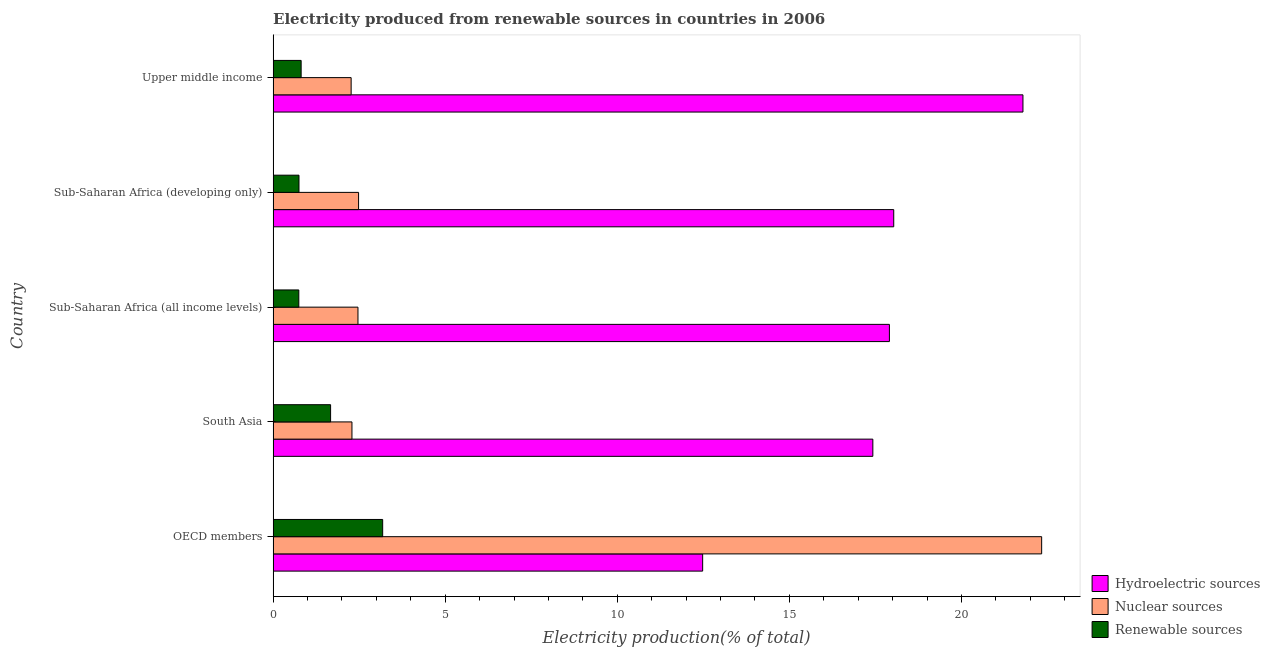How many different coloured bars are there?
Keep it short and to the point. 3. Are the number of bars per tick equal to the number of legend labels?
Ensure brevity in your answer.  Yes. Are the number of bars on each tick of the Y-axis equal?
Offer a terse response. Yes. How many bars are there on the 2nd tick from the bottom?
Offer a very short reply. 3. In how many cases, is the number of bars for a given country not equal to the number of legend labels?
Make the answer very short. 0. What is the percentage of electricity produced by nuclear sources in South Asia?
Provide a succinct answer. 2.29. Across all countries, what is the maximum percentage of electricity produced by renewable sources?
Your answer should be compact. 3.18. Across all countries, what is the minimum percentage of electricity produced by renewable sources?
Give a very brief answer. 0.75. In which country was the percentage of electricity produced by renewable sources minimum?
Ensure brevity in your answer.  Sub-Saharan Africa (all income levels). What is the total percentage of electricity produced by hydroelectric sources in the graph?
Your answer should be very brief. 87.63. What is the difference between the percentage of electricity produced by renewable sources in OECD members and that in South Asia?
Offer a terse response. 1.51. What is the difference between the percentage of electricity produced by renewable sources in Sub-Saharan Africa (developing only) and the percentage of electricity produced by hydroelectric sources in OECD members?
Make the answer very short. -11.73. What is the average percentage of electricity produced by nuclear sources per country?
Your answer should be very brief. 6.37. What is the difference between the percentage of electricity produced by hydroelectric sources and percentage of electricity produced by renewable sources in Upper middle income?
Offer a very short reply. 20.97. What is the ratio of the percentage of electricity produced by hydroelectric sources in OECD members to that in Sub-Saharan Africa (developing only)?
Provide a short and direct response. 0.69. Is the percentage of electricity produced by renewable sources in OECD members less than that in Sub-Saharan Africa (developing only)?
Your answer should be very brief. No. What is the difference between the highest and the second highest percentage of electricity produced by renewable sources?
Provide a succinct answer. 1.51. What is the difference between the highest and the lowest percentage of electricity produced by nuclear sources?
Your answer should be compact. 20.06. In how many countries, is the percentage of electricity produced by renewable sources greater than the average percentage of electricity produced by renewable sources taken over all countries?
Offer a very short reply. 2. Is the sum of the percentage of electricity produced by renewable sources in OECD members and South Asia greater than the maximum percentage of electricity produced by hydroelectric sources across all countries?
Your answer should be very brief. No. What does the 3rd bar from the top in South Asia represents?
Your response must be concise. Hydroelectric sources. What does the 2nd bar from the bottom in Sub-Saharan Africa (developing only) represents?
Offer a very short reply. Nuclear sources. Is it the case that in every country, the sum of the percentage of electricity produced by hydroelectric sources and percentage of electricity produced by nuclear sources is greater than the percentage of electricity produced by renewable sources?
Keep it short and to the point. Yes. How many bars are there?
Provide a succinct answer. 15. What is the difference between two consecutive major ticks on the X-axis?
Your answer should be very brief. 5. Does the graph contain any zero values?
Offer a very short reply. No. How are the legend labels stacked?
Your answer should be compact. Vertical. What is the title of the graph?
Offer a very short reply. Electricity produced from renewable sources in countries in 2006. What is the label or title of the X-axis?
Keep it short and to the point. Electricity production(% of total). What is the Electricity production(% of total) of Hydroelectric sources in OECD members?
Keep it short and to the point. 12.48. What is the Electricity production(% of total) of Nuclear sources in OECD members?
Your answer should be compact. 22.33. What is the Electricity production(% of total) of Renewable sources in OECD members?
Offer a very short reply. 3.18. What is the Electricity production(% of total) of Hydroelectric sources in South Asia?
Your response must be concise. 17.43. What is the Electricity production(% of total) in Nuclear sources in South Asia?
Offer a very short reply. 2.29. What is the Electricity production(% of total) of Renewable sources in South Asia?
Your answer should be very brief. 1.67. What is the Electricity production(% of total) of Hydroelectric sources in Sub-Saharan Africa (all income levels)?
Offer a terse response. 17.91. What is the Electricity production(% of total) of Nuclear sources in Sub-Saharan Africa (all income levels)?
Your answer should be very brief. 2.47. What is the Electricity production(% of total) of Renewable sources in Sub-Saharan Africa (all income levels)?
Provide a succinct answer. 0.75. What is the Electricity production(% of total) in Hydroelectric sources in Sub-Saharan Africa (developing only)?
Offer a terse response. 18.03. What is the Electricity production(% of total) of Nuclear sources in Sub-Saharan Africa (developing only)?
Provide a short and direct response. 2.48. What is the Electricity production(% of total) of Renewable sources in Sub-Saharan Africa (developing only)?
Your answer should be very brief. 0.75. What is the Electricity production(% of total) in Hydroelectric sources in Upper middle income?
Ensure brevity in your answer.  21.79. What is the Electricity production(% of total) of Nuclear sources in Upper middle income?
Keep it short and to the point. 2.27. What is the Electricity production(% of total) of Renewable sources in Upper middle income?
Offer a terse response. 0.81. Across all countries, what is the maximum Electricity production(% of total) of Hydroelectric sources?
Your answer should be compact. 21.79. Across all countries, what is the maximum Electricity production(% of total) in Nuclear sources?
Your answer should be very brief. 22.33. Across all countries, what is the maximum Electricity production(% of total) in Renewable sources?
Provide a succinct answer. 3.18. Across all countries, what is the minimum Electricity production(% of total) of Hydroelectric sources?
Your answer should be very brief. 12.48. Across all countries, what is the minimum Electricity production(% of total) in Nuclear sources?
Ensure brevity in your answer.  2.27. Across all countries, what is the minimum Electricity production(% of total) in Renewable sources?
Make the answer very short. 0.75. What is the total Electricity production(% of total) of Hydroelectric sources in the graph?
Provide a short and direct response. 87.63. What is the total Electricity production(% of total) in Nuclear sources in the graph?
Your answer should be very brief. 31.84. What is the total Electricity production(% of total) of Renewable sources in the graph?
Your answer should be compact. 7.17. What is the difference between the Electricity production(% of total) of Hydroelectric sources in OECD members and that in South Asia?
Your response must be concise. -4.95. What is the difference between the Electricity production(% of total) in Nuclear sources in OECD members and that in South Asia?
Provide a succinct answer. 20.04. What is the difference between the Electricity production(% of total) in Renewable sources in OECD members and that in South Asia?
Your answer should be very brief. 1.51. What is the difference between the Electricity production(% of total) of Hydroelectric sources in OECD members and that in Sub-Saharan Africa (all income levels)?
Provide a short and direct response. -5.43. What is the difference between the Electricity production(% of total) of Nuclear sources in OECD members and that in Sub-Saharan Africa (all income levels)?
Provide a succinct answer. 19.86. What is the difference between the Electricity production(% of total) of Renewable sources in OECD members and that in Sub-Saharan Africa (all income levels)?
Give a very brief answer. 2.44. What is the difference between the Electricity production(% of total) of Hydroelectric sources in OECD members and that in Sub-Saharan Africa (developing only)?
Your response must be concise. -5.55. What is the difference between the Electricity production(% of total) in Nuclear sources in OECD members and that in Sub-Saharan Africa (developing only)?
Your response must be concise. 19.85. What is the difference between the Electricity production(% of total) of Renewable sources in OECD members and that in Sub-Saharan Africa (developing only)?
Keep it short and to the point. 2.43. What is the difference between the Electricity production(% of total) of Hydroelectric sources in OECD members and that in Upper middle income?
Provide a succinct answer. -9.31. What is the difference between the Electricity production(% of total) of Nuclear sources in OECD members and that in Upper middle income?
Your answer should be very brief. 20.06. What is the difference between the Electricity production(% of total) of Renewable sources in OECD members and that in Upper middle income?
Offer a very short reply. 2.37. What is the difference between the Electricity production(% of total) in Hydroelectric sources in South Asia and that in Sub-Saharan Africa (all income levels)?
Your answer should be compact. -0.48. What is the difference between the Electricity production(% of total) of Nuclear sources in South Asia and that in Sub-Saharan Africa (all income levels)?
Your response must be concise. -0.17. What is the difference between the Electricity production(% of total) in Renewable sources in South Asia and that in Sub-Saharan Africa (all income levels)?
Provide a succinct answer. 0.92. What is the difference between the Electricity production(% of total) of Hydroelectric sources in South Asia and that in Sub-Saharan Africa (developing only)?
Keep it short and to the point. -0.61. What is the difference between the Electricity production(% of total) of Nuclear sources in South Asia and that in Sub-Saharan Africa (developing only)?
Provide a succinct answer. -0.19. What is the difference between the Electricity production(% of total) of Renewable sources in South Asia and that in Sub-Saharan Africa (developing only)?
Your response must be concise. 0.92. What is the difference between the Electricity production(% of total) in Hydroelectric sources in South Asia and that in Upper middle income?
Give a very brief answer. -4.36. What is the difference between the Electricity production(% of total) in Nuclear sources in South Asia and that in Upper middle income?
Provide a short and direct response. 0.02. What is the difference between the Electricity production(% of total) in Renewable sources in South Asia and that in Upper middle income?
Offer a very short reply. 0.86. What is the difference between the Electricity production(% of total) in Hydroelectric sources in Sub-Saharan Africa (all income levels) and that in Sub-Saharan Africa (developing only)?
Your answer should be compact. -0.13. What is the difference between the Electricity production(% of total) of Nuclear sources in Sub-Saharan Africa (all income levels) and that in Sub-Saharan Africa (developing only)?
Provide a succinct answer. -0.02. What is the difference between the Electricity production(% of total) in Renewable sources in Sub-Saharan Africa (all income levels) and that in Sub-Saharan Africa (developing only)?
Ensure brevity in your answer.  -0.01. What is the difference between the Electricity production(% of total) in Hydroelectric sources in Sub-Saharan Africa (all income levels) and that in Upper middle income?
Your answer should be compact. -3.88. What is the difference between the Electricity production(% of total) of Nuclear sources in Sub-Saharan Africa (all income levels) and that in Upper middle income?
Your answer should be compact. 0.2. What is the difference between the Electricity production(% of total) in Renewable sources in Sub-Saharan Africa (all income levels) and that in Upper middle income?
Your answer should be compact. -0.07. What is the difference between the Electricity production(% of total) in Hydroelectric sources in Sub-Saharan Africa (developing only) and that in Upper middle income?
Offer a very short reply. -3.75. What is the difference between the Electricity production(% of total) in Nuclear sources in Sub-Saharan Africa (developing only) and that in Upper middle income?
Offer a very short reply. 0.22. What is the difference between the Electricity production(% of total) in Renewable sources in Sub-Saharan Africa (developing only) and that in Upper middle income?
Provide a short and direct response. -0.06. What is the difference between the Electricity production(% of total) in Hydroelectric sources in OECD members and the Electricity production(% of total) in Nuclear sources in South Asia?
Keep it short and to the point. 10.19. What is the difference between the Electricity production(% of total) in Hydroelectric sources in OECD members and the Electricity production(% of total) in Renewable sources in South Asia?
Keep it short and to the point. 10.81. What is the difference between the Electricity production(% of total) of Nuclear sources in OECD members and the Electricity production(% of total) of Renewable sources in South Asia?
Your answer should be very brief. 20.66. What is the difference between the Electricity production(% of total) of Hydroelectric sources in OECD members and the Electricity production(% of total) of Nuclear sources in Sub-Saharan Africa (all income levels)?
Your answer should be compact. 10.01. What is the difference between the Electricity production(% of total) of Hydroelectric sources in OECD members and the Electricity production(% of total) of Renewable sources in Sub-Saharan Africa (all income levels)?
Your answer should be compact. 11.73. What is the difference between the Electricity production(% of total) in Nuclear sources in OECD members and the Electricity production(% of total) in Renewable sources in Sub-Saharan Africa (all income levels)?
Ensure brevity in your answer.  21.58. What is the difference between the Electricity production(% of total) of Hydroelectric sources in OECD members and the Electricity production(% of total) of Nuclear sources in Sub-Saharan Africa (developing only)?
Ensure brevity in your answer.  10. What is the difference between the Electricity production(% of total) in Hydroelectric sources in OECD members and the Electricity production(% of total) in Renewable sources in Sub-Saharan Africa (developing only)?
Your answer should be very brief. 11.73. What is the difference between the Electricity production(% of total) of Nuclear sources in OECD members and the Electricity production(% of total) of Renewable sources in Sub-Saharan Africa (developing only)?
Give a very brief answer. 21.58. What is the difference between the Electricity production(% of total) of Hydroelectric sources in OECD members and the Electricity production(% of total) of Nuclear sources in Upper middle income?
Offer a terse response. 10.21. What is the difference between the Electricity production(% of total) in Hydroelectric sources in OECD members and the Electricity production(% of total) in Renewable sources in Upper middle income?
Give a very brief answer. 11.67. What is the difference between the Electricity production(% of total) of Nuclear sources in OECD members and the Electricity production(% of total) of Renewable sources in Upper middle income?
Keep it short and to the point. 21.52. What is the difference between the Electricity production(% of total) in Hydroelectric sources in South Asia and the Electricity production(% of total) in Nuclear sources in Sub-Saharan Africa (all income levels)?
Your answer should be very brief. 14.96. What is the difference between the Electricity production(% of total) in Hydroelectric sources in South Asia and the Electricity production(% of total) in Renewable sources in Sub-Saharan Africa (all income levels)?
Give a very brief answer. 16.68. What is the difference between the Electricity production(% of total) in Nuclear sources in South Asia and the Electricity production(% of total) in Renewable sources in Sub-Saharan Africa (all income levels)?
Offer a very short reply. 1.54. What is the difference between the Electricity production(% of total) in Hydroelectric sources in South Asia and the Electricity production(% of total) in Nuclear sources in Sub-Saharan Africa (developing only)?
Your response must be concise. 14.94. What is the difference between the Electricity production(% of total) of Hydroelectric sources in South Asia and the Electricity production(% of total) of Renewable sources in Sub-Saharan Africa (developing only)?
Ensure brevity in your answer.  16.67. What is the difference between the Electricity production(% of total) of Nuclear sources in South Asia and the Electricity production(% of total) of Renewable sources in Sub-Saharan Africa (developing only)?
Your response must be concise. 1.54. What is the difference between the Electricity production(% of total) of Hydroelectric sources in South Asia and the Electricity production(% of total) of Nuclear sources in Upper middle income?
Keep it short and to the point. 15.16. What is the difference between the Electricity production(% of total) of Hydroelectric sources in South Asia and the Electricity production(% of total) of Renewable sources in Upper middle income?
Ensure brevity in your answer.  16.61. What is the difference between the Electricity production(% of total) of Nuclear sources in South Asia and the Electricity production(% of total) of Renewable sources in Upper middle income?
Your answer should be very brief. 1.48. What is the difference between the Electricity production(% of total) in Hydroelectric sources in Sub-Saharan Africa (all income levels) and the Electricity production(% of total) in Nuclear sources in Sub-Saharan Africa (developing only)?
Keep it short and to the point. 15.42. What is the difference between the Electricity production(% of total) of Hydroelectric sources in Sub-Saharan Africa (all income levels) and the Electricity production(% of total) of Renewable sources in Sub-Saharan Africa (developing only)?
Make the answer very short. 17.15. What is the difference between the Electricity production(% of total) in Nuclear sources in Sub-Saharan Africa (all income levels) and the Electricity production(% of total) in Renewable sources in Sub-Saharan Africa (developing only)?
Your answer should be very brief. 1.71. What is the difference between the Electricity production(% of total) of Hydroelectric sources in Sub-Saharan Africa (all income levels) and the Electricity production(% of total) of Nuclear sources in Upper middle income?
Offer a terse response. 15.64. What is the difference between the Electricity production(% of total) of Hydroelectric sources in Sub-Saharan Africa (all income levels) and the Electricity production(% of total) of Renewable sources in Upper middle income?
Offer a terse response. 17.09. What is the difference between the Electricity production(% of total) of Nuclear sources in Sub-Saharan Africa (all income levels) and the Electricity production(% of total) of Renewable sources in Upper middle income?
Provide a succinct answer. 1.65. What is the difference between the Electricity production(% of total) of Hydroelectric sources in Sub-Saharan Africa (developing only) and the Electricity production(% of total) of Nuclear sources in Upper middle income?
Keep it short and to the point. 15.76. What is the difference between the Electricity production(% of total) in Hydroelectric sources in Sub-Saharan Africa (developing only) and the Electricity production(% of total) in Renewable sources in Upper middle income?
Provide a succinct answer. 17.22. What is the difference between the Electricity production(% of total) in Nuclear sources in Sub-Saharan Africa (developing only) and the Electricity production(% of total) in Renewable sources in Upper middle income?
Give a very brief answer. 1.67. What is the average Electricity production(% of total) in Hydroelectric sources per country?
Make the answer very short. 17.53. What is the average Electricity production(% of total) in Nuclear sources per country?
Ensure brevity in your answer.  6.37. What is the average Electricity production(% of total) of Renewable sources per country?
Offer a terse response. 1.43. What is the difference between the Electricity production(% of total) in Hydroelectric sources and Electricity production(% of total) in Nuclear sources in OECD members?
Keep it short and to the point. -9.85. What is the difference between the Electricity production(% of total) of Hydroelectric sources and Electricity production(% of total) of Renewable sources in OECD members?
Give a very brief answer. 9.3. What is the difference between the Electricity production(% of total) in Nuclear sources and Electricity production(% of total) in Renewable sources in OECD members?
Your answer should be very brief. 19.15. What is the difference between the Electricity production(% of total) in Hydroelectric sources and Electricity production(% of total) in Nuclear sources in South Asia?
Offer a very short reply. 15.13. What is the difference between the Electricity production(% of total) of Hydroelectric sources and Electricity production(% of total) of Renewable sources in South Asia?
Your response must be concise. 15.76. What is the difference between the Electricity production(% of total) in Nuclear sources and Electricity production(% of total) in Renewable sources in South Asia?
Your response must be concise. 0.62. What is the difference between the Electricity production(% of total) of Hydroelectric sources and Electricity production(% of total) of Nuclear sources in Sub-Saharan Africa (all income levels)?
Your answer should be very brief. 15.44. What is the difference between the Electricity production(% of total) of Hydroelectric sources and Electricity production(% of total) of Renewable sources in Sub-Saharan Africa (all income levels)?
Your answer should be very brief. 17.16. What is the difference between the Electricity production(% of total) of Nuclear sources and Electricity production(% of total) of Renewable sources in Sub-Saharan Africa (all income levels)?
Your response must be concise. 1.72. What is the difference between the Electricity production(% of total) of Hydroelectric sources and Electricity production(% of total) of Nuclear sources in Sub-Saharan Africa (developing only)?
Provide a succinct answer. 15.55. What is the difference between the Electricity production(% of total) of Hydroelectric sources and Electricity production(% of total) of Renewable sources in Sub-Saharan Africa (developing only)?
Make the answer very short. 17.28. What is the difference between the Electricity production(% of total) in Nuclear sources and Electricity production(% of total) in Renewable sources in Sub-Saharan Africa (developing only)?
Offer a very short reply. 1.73. What is the difference between the Electricity production(% of total) of Hydroelectric sources and Electricity production(% of total) of Nuclear sources in Upper middle income?
Offer a terse response. 19.52. What is the difference between the Electricity production(% of total) in Hydroelectric sources and Electricity production(% of total) in Renewable sources in Upper middle income?
Provide a succinct answer. 20.97. What is the difference between the Electricity production(% of total) in Nuclear sources and Electricity production(% of total) in Renewable sources in Upper middle income?
Your response must be concise. 1.45. What is the ratio of the Electricity production(% of total) of Hydroelectric sources in OECD members to that in South Asia?
Make the answer very short. 0.72. What is the ratio of the Electricity production(% of total) of Nuclear sources in OECD members to that in South Asia?
Offer a very short reply. 9.75. What is the ratio of the Electricity production(% of total) in Renewable sources in OECD members to that in South Asia?
Offer a terse response. 1.91. What is the ratio of the Electricity production(% of total) in Hydroelectric sources in OECD members to that in Sub-Saharan Africa (all income levels)?
Offer a very short reply. 0.7. What is the ratio of the Electricity production(% of total) of Nuclear sources in OECD members to that in Sub-Saharan Africa (all income levels)?
Your answer should be very brief. 9.06. What is the ratio of the Electricity production(% of total) of Renewable sources in OECD members to that in Sub-Saharan Africa (all income levels)?
Keep it short and to the point. 4.26. What is the ratio of the Electricity production(% of total) of Hydroelectric sources in OECD members to that in Sub-Saharan Africa (developing only)?
Your answer should be compact. 0.69. What is the ratio of the Electricity production(% of total) of Nuclear sources in OECD members to that in Sub-Saharan Africa (developing only)?
Give a very brief answer. 8.99. What is the ratio of the Electricity production(% of total) in Renewable sources in OECD members to that in Sub-Saharan Africa (developing only)?
Provide a succinct answer. 4.24. What is the ratio of the Electricity production(% of total) of Hydroelectric sources in OECD members to that in Upper middle income?
Your answer should be very brief. 0.57. What is the ratio of the Electricity production(% of total) of Nuclear sources in OECD members to that in Upper middle income?
Provide a succinct answer. 9.85. What is the ratio of the Electricity production(% of total) in Renewable sources in OECD members to that in Upper middle income?
Offer a very short reply. 3.91. What is the ratio of the Electricity production(% of total) of Hydroelectric sources in South Asia to that in Sub-Saharan Africa (all income levels)?
Your answer should be compact. 0.97. What is the ratio of the Electricity production(% of total) in Nuclear sources in South Asia to that in Sub-Saharan Africa (all income levels)?
Your answer should be compact. 0.93. What is the ratio of the Electricity production(% of total) of Renewable sources in South Asia to that in Sub-Saharan Africa (all income levels)?
Provide a short and direct response. 2.24. What is the ratio of the Electricity production(% of total) in Hydroelectric sources in South Asia to that in Sub-Saharan Africa (developing only)?
Give a very brief answer. 0.97. What is the ratio of the Electricity production(% of total) in Nuclear sources in South Asia to that in Sub-Saharan Africa (developing only)?
Provide a short and direct response. 0.92. What is the ratio of the Electricity production(% of total) of Renewable sources in South Asia to that in Sub-Saharan Africa (developing only)?
Give a very brief answer. 2.22. What is the ratio of the Electricity production(% of total) in Hydroelectric sources in South Asia to that in Upper middle income?
Offer a terse response. 0.8. What is the ratio of the Electricity production(% of total) in Nuclear sources in South Asia to that in Upper middle income?
Your response must be concise. 1.01. What is the ratio of the Electricity production(% of total) of Renewable sources in South Asia to that in Upper middle income?
Offer a terse response. 2.05. What is the ratio of the Electricity production(% of total) in Hydroelectric sources in Sub-Saharan Africa (all income levels) to that in Sub-Saharan Africa (developing only)?
Ensure brevity in your answer.  0.99. What is the ratio of the Electricity production(% of total) of Hydroelectric sources in Sub-Saharan Africa (all income levels) to that in Upper middle income?
Your answer should be compact. 0.82. What is the ratio of the Electricity production(% of total) in Nuclear sources in Sub-Saharan Africa (all income levels) to that in Upper middle income?
Offer a terse response. 1.09. What is the ratio of the Electricity production(% of total) in Renewable sources in Sub-Saharan Africa (all income levels) to that in Upper middle income?
Ensure brevity in your answer.  0.92. What is the ratio of the Electricity production(% of total) in Hydroelectric sources in Sub-Saharan Africa (developing only) to that in Upper middle income?
Keep it short and to the point. 0.83. What is the ratio of the Electricity production(% of total) in Nuclear sources in Sub-Saharan Africa (developing only) to that in Upper middle income?
Your answer should be very brief. 1.1. What is the ratio of the Electricity production(% of total) of Renewable sources in Sub-Saharan Africa (developing only) to that in Upper middle income?
Keep it short and to the point. 0.92. What is the difference between the highest and the second highest Electricity production(% of total) of Hydroelectric sources?
Your response must be concise. 3.75. What is the difference between the highest and the second highest Electricity production(% of total) of Nuclear sources?
Provide a short and direct response. 19.85. What is the difference between the highest and the second highest Electricity production(% of total) in Renewable sources?
Provide a short and direct response. 1.51. What is the difference between the highest and the lowest Electricity production(% of total) in Hydroelectric sources?
Your answer should be compact. 9.31. What is the difference between the highest and the lowest Electricity production(% of total) of Nuclear sources?
Ensure brevity in your answer.  20.06. What is the difference between the highest and the lowest Electricity production(% of total) of Renewable sources?
Provide a short and direct response. 2.44. 